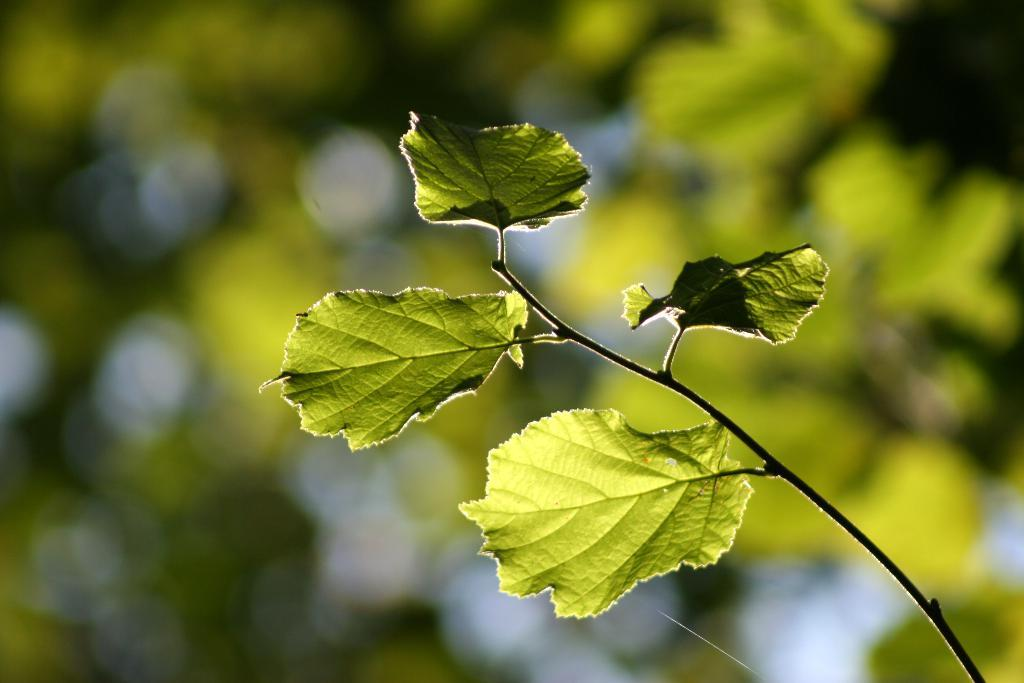What is the main object in the image? There is a branch in the image. Can you describe the background of the image? The background of the image is blurred. What type of honey is dripping from the branch in the image? There is no honey present in the image; it only features a branch with no visible substances dripping from it. 